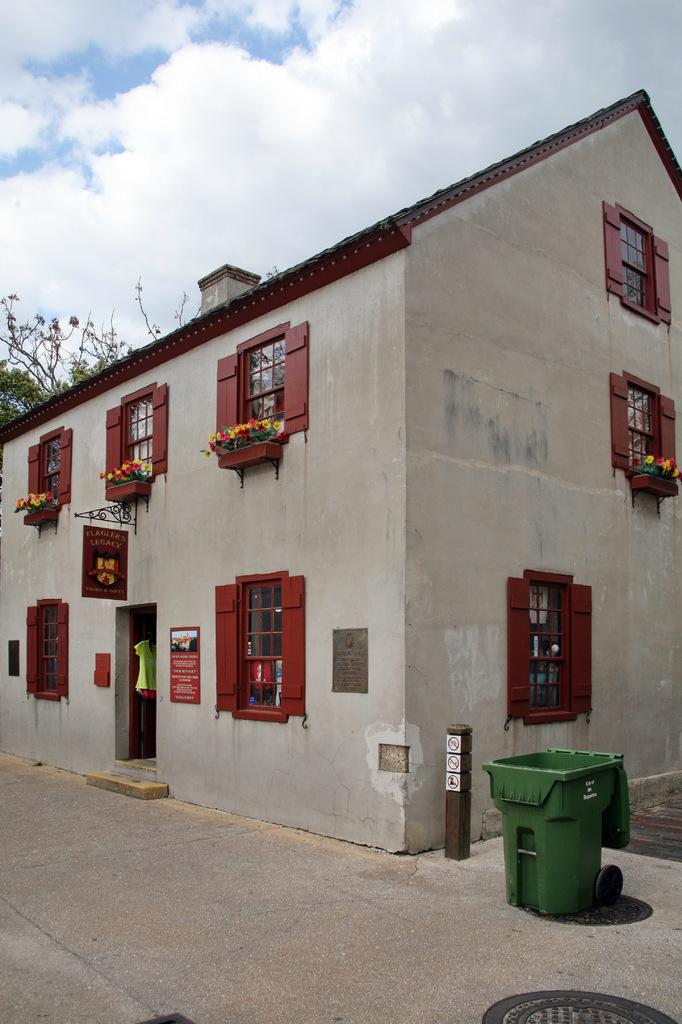What type of building is shown in the image? The building in the image has glass windows and a door. Are there any objects near the building? Yes, there is a trash can beside the building. What can be seen on the other side of the building? There is a tree on the other side of the building. How many brothers are playing during the recess in the image? There is no reference to brothers or a recess in the image; it features a building, a trash can, and a tree. 